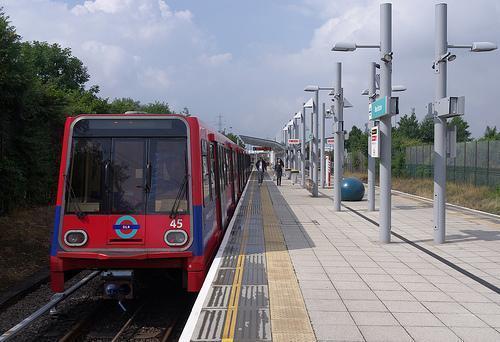How many people can be seen?
Give a very brief answer. 2. 